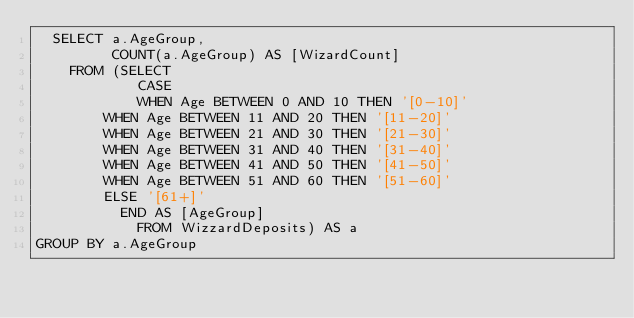<code> <loc_0><loc_0><loc_500><loc_500><_SQL_>  SELECT a.AgeGroup, 
         COUNT(a.AgeGroup) AS [WizardCount]
    FROM (SELECT
            CASE
	        WHEN Age BETWEEN 0 AND 10 THEN '[0-10]'
		WHEN Age BETWEEN 11 AND 20 THEN '[11-20]'
		WHEN Age BETWEEN 21 AND 30 THEN '[21-30]'
		WHEN Age BETWEEN 31 AND 40 THEN '[31-40]'
		WHEN Age BETWEEN 41 AND 50 THEN '[41-50]'
		WHEN Age BETWEEN 51 AND 60 THEN '[51-60]'
		ELSE '[61+]'
          END AS [AgeGroup]
            FROM WizzardDeposits) AS a
GROUP BY a.AgeGroup
</code> 